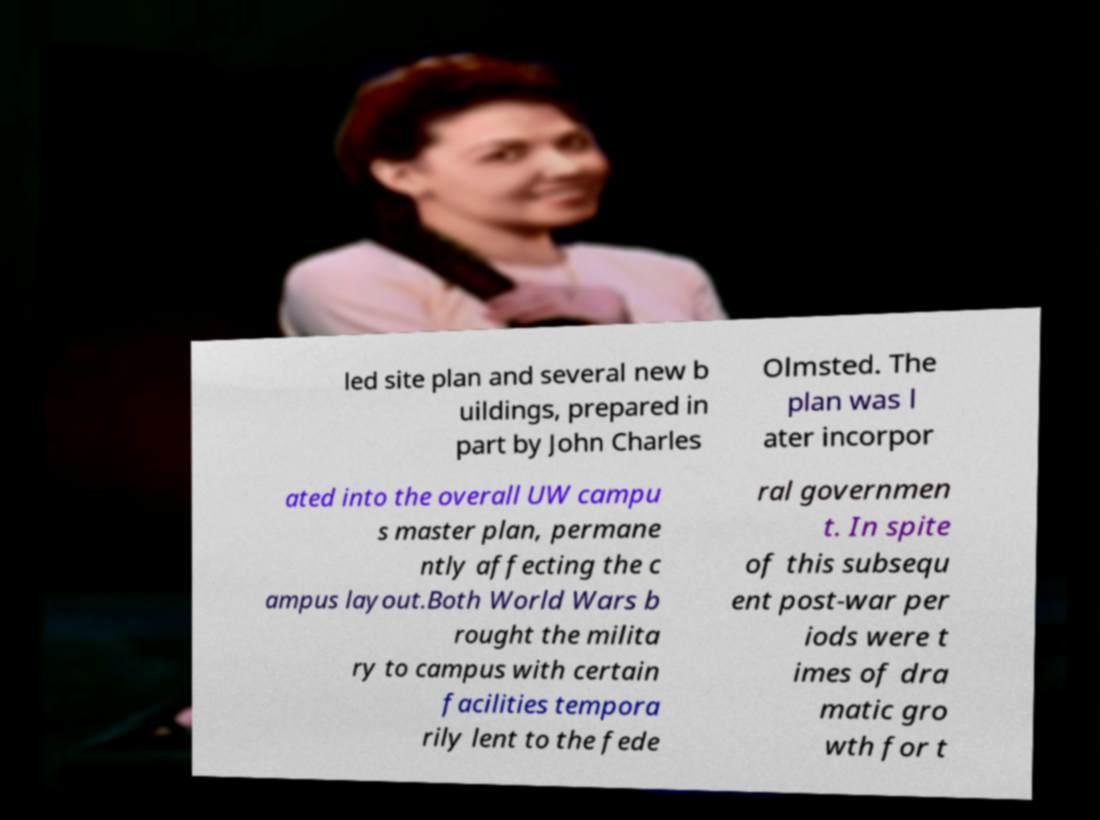I need the written content from this picture converted into text. Can you do that? led site plan and several new b uildings, prepared in part by John Charles Olmsted. The plan was l ater incorpor ated into the overall UW campu s master plan, permane ntly affecting the c ampus layout.Both World Wars b rought the milita ry to campus with certain facilities tempora rily lent to the fede ral governmen t. In spite of this subsequ ent post-war per iods were t imes of dra matic gro wth for t 